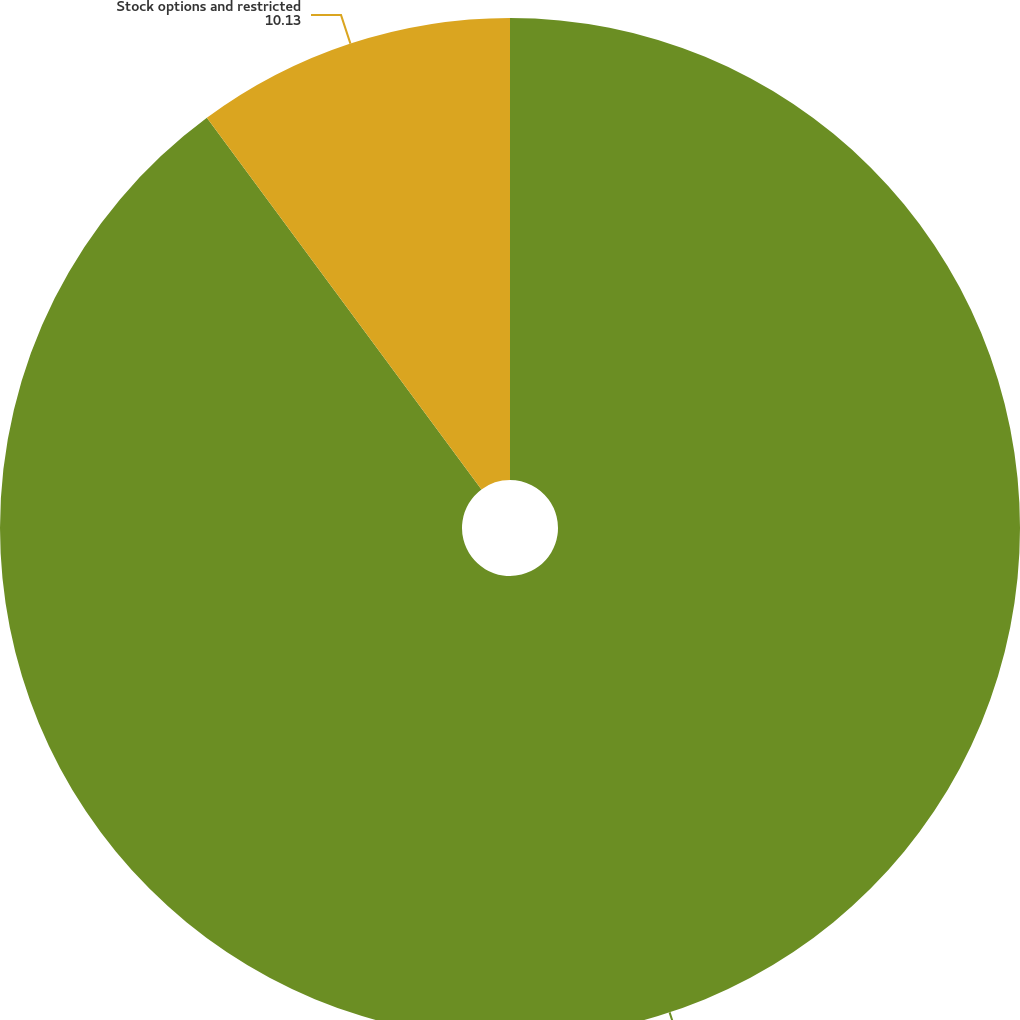<chart> <loc_0><loc_0><loc_500><loc_500><pie_chart><fcel>Weighted average number of<fcel>Stock options and restricted<nl><fcel>89.87%<fcel>10.13%<nl></chart> 